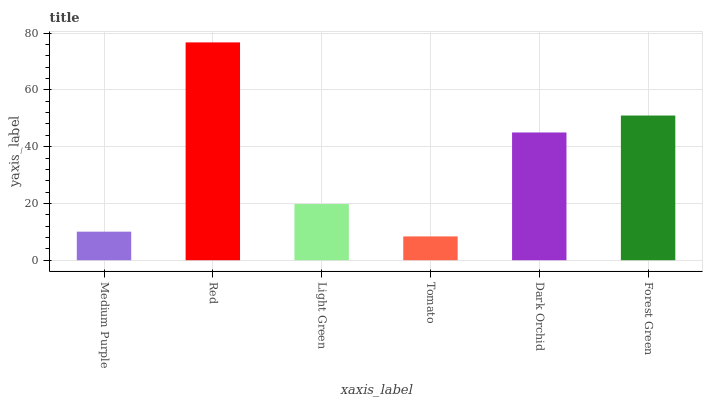Is Light Green the minimum?
Answer yes or no. No. Is Light Green the maximum?
Answer yes or no. No. Is Red greater than Light Green?
Answer yes or no. Yes. Is Light Green less than Red?
Answer yes or no. Yes. Is Light Green greater than Red?
Answer yes or no. No. Is Red less than Light Green?
Answer yes or no. No. Is Dark Orchid the high median?
Answer yes or no. Yes. Is Light Green the low median?
Answer yes or no. Yes. Is Light Green the high median?
Answer yes or no. No. Is Tomato the low median?
Answer yes or no. No. 